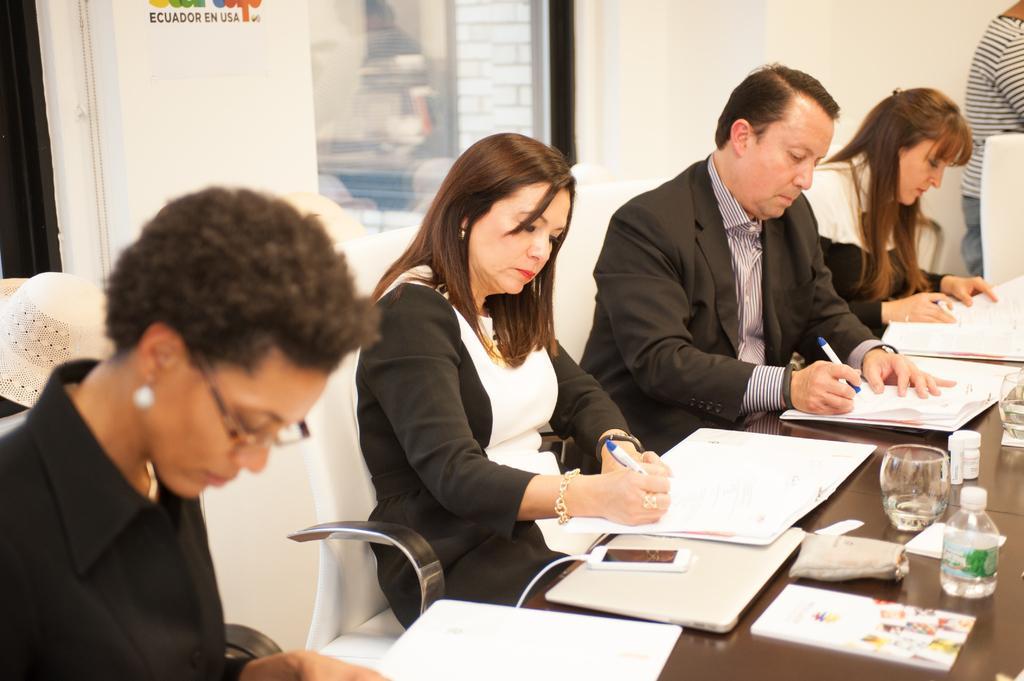Could you give a brief overview of what you see in this image? In this picture we can see people, chairs, table, files, pens, glasses, bottle, books, mobile and various objects. In the background we can see wall and window. 